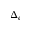Convert formula to latex. <formula><loc_0><loc_0><loc_500><loc_500>\Delta _ { e }</formula> 